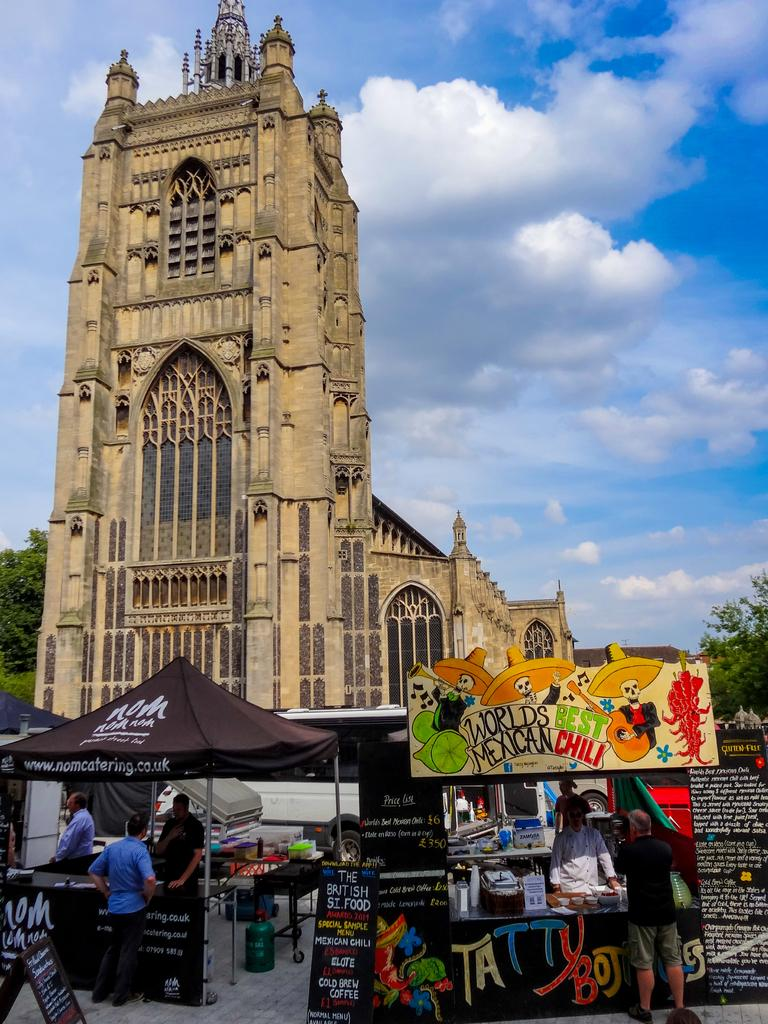What type of structure is visible in the image? There is a building in the image. What is located in front of the building? There are tents in front of the building. What mode of transportation can be seen in the image? A vehicle is present in the image. What type of advertisements or signs are visible in the image? There are hoardings in the image. Can you describe the people in the image? There are people in the image. What type of natural elements can be seen in the background of the image? There are trees and clouds visible in the background of the image. What type of linen is draped over the trees in the image? There is no linen draped over the trees in the image; only trees and clouds are visible in the background. What is the shape of the clouds in the image? The shape of the clouds cannot be determined from the image, as they are not described in the provided facts. 